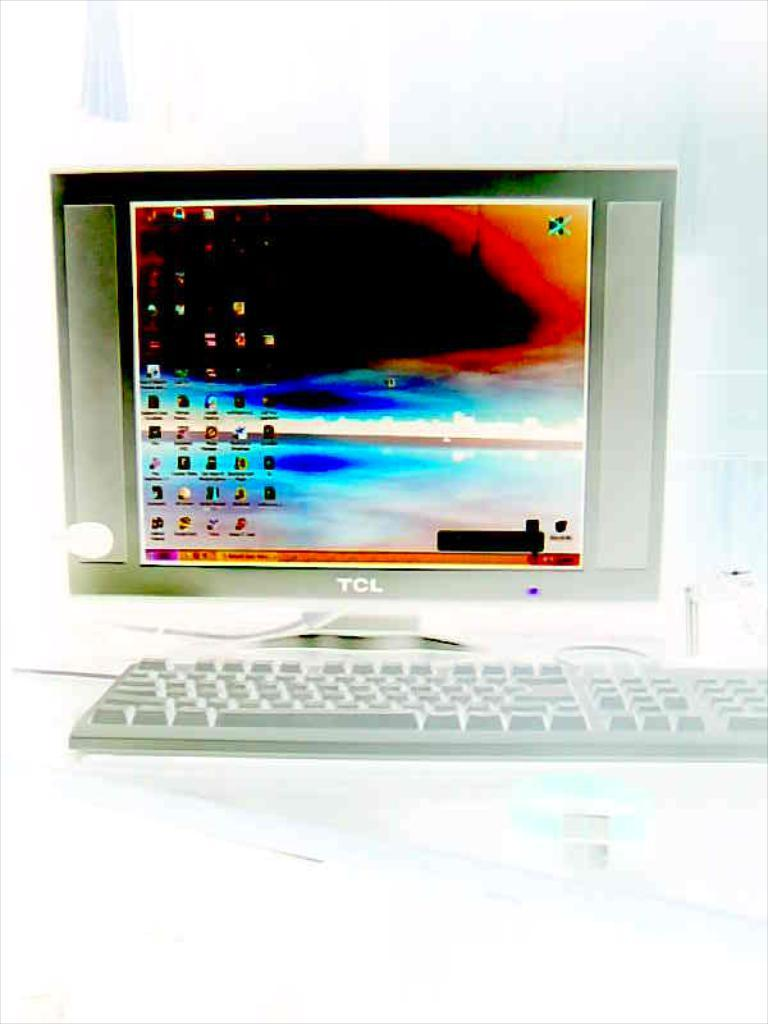<image>
Describe the image concisely. A TCL computer with keyboard is shown in an xray machine. 